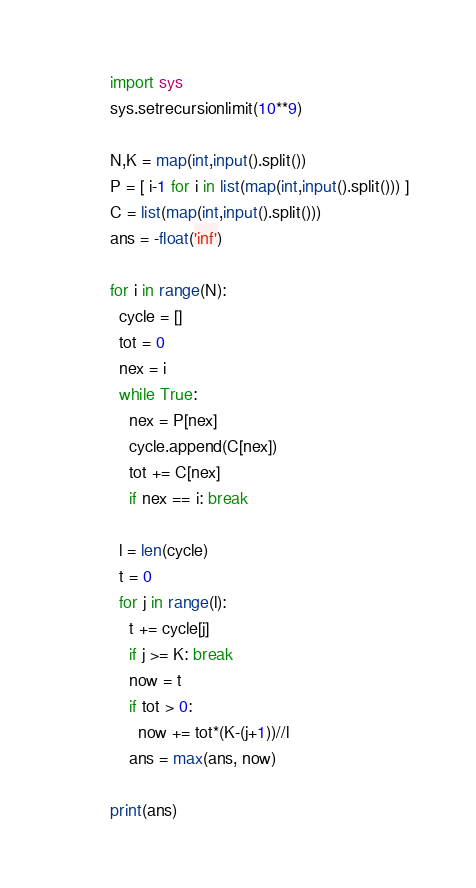<code> <loc_0><loc_0><loc_500><loc_500><_Python_>import sys
sys.setrecursionlimit(10**9)

N,K = map(int,input().split())
P = [ i-1 for i in list(map(int,input().split())) ]
C = list(map(int,input().split()))
ans = -float('inf')

for i in range(N):
  cycle = []
  tot = 0
  nex = i
  while True:
    nex = P[nex]
    cycle.append(C[nex])
    tot += C[nex]
    if nex == i: break

  l = len(cycle)
  t = 0
  for j in range(l):
    t += cycle[j]
    if j >= K: break
    now = t
    if tot > 0:
      now += tot*(K-(j+1))//l
    ans = max(ans, now)

print(ans)</code> 